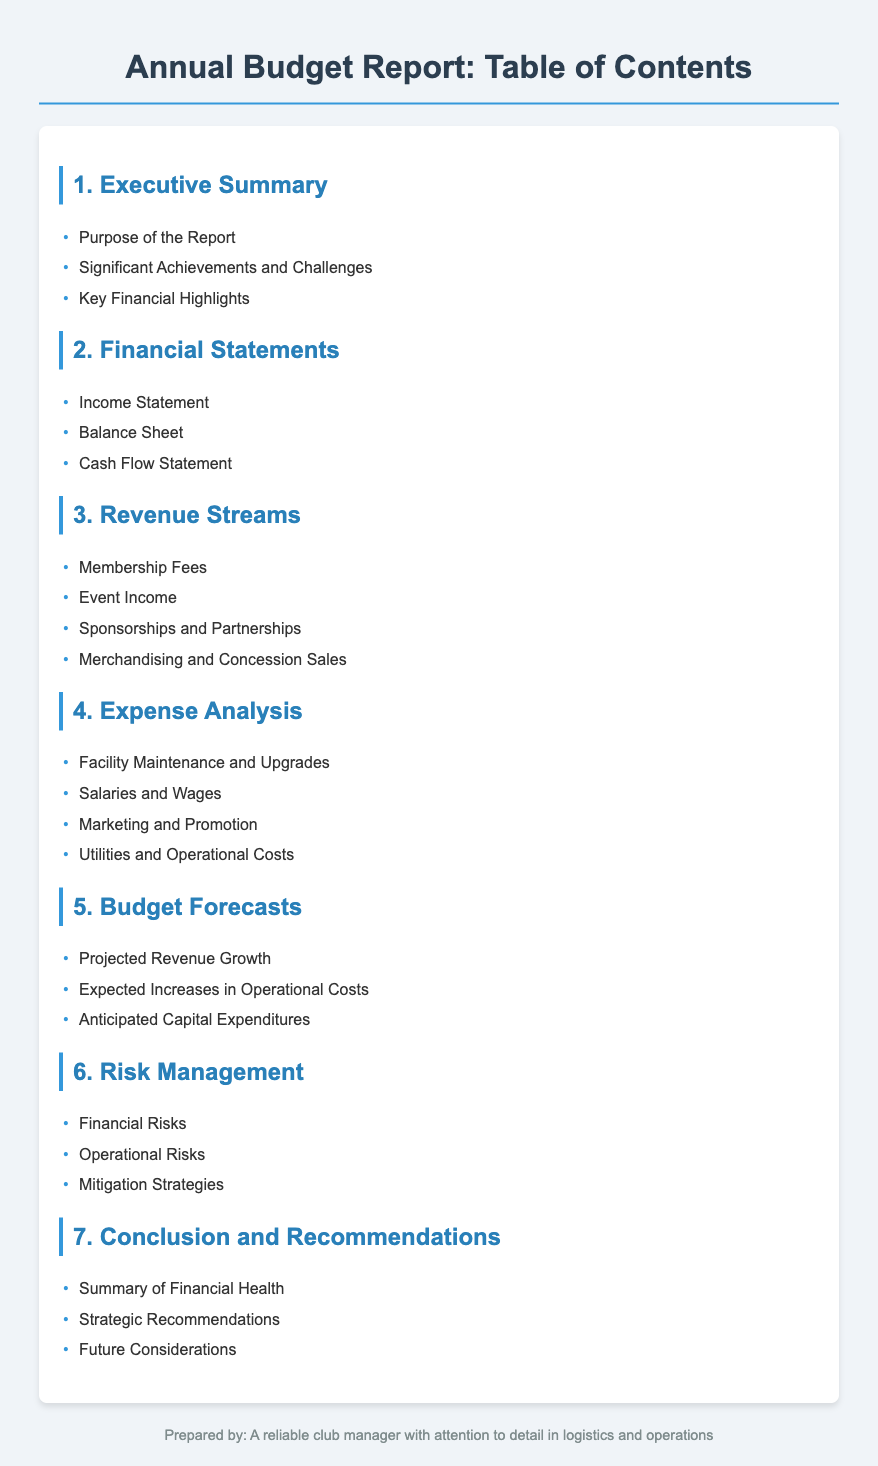What is the purpose of the report? The purpose of the report is mentioned in the Executive Summary section.
Answer: Purpose of the Report How many financial statements are listed? The Financial Statements section includes three documents.
Answer: 3 What are the revenue streams mentioned? The Revenue Streams section outlines several income sources.
Answer: Membership Fees, Event Income, Sponsorships and Partnerships, Merchandising and Concession Sales What is included in the Expense Analysis? The Expense Analysis detail covers various financial obligations, listed in the document.
Answer: Facility Maintenance and Upgrades, Salaries and Wages, Marketing and Promotion, Utilities and Operational Costs What key aspect does the Budget Forecasts section focus on? The Budget Forecasts section highlights projected changes in finances.
Answer: Projected Revenue Growth, Expected Increases in Operational Costs, Anticipated Capital Expenditures What are the risks identified in the Risk Management section? The Risk Management section tackles specific potential issues the club might face.
Answer: Financial Risks, Operational Risks What summary is provided in the Conclusion and Recommendations? The Conclusion and Recommendations section summarizes the overall financial health status and suggestions.
Answer: Summary of Financial Health, Strategic Recommendations, Future Considerations 